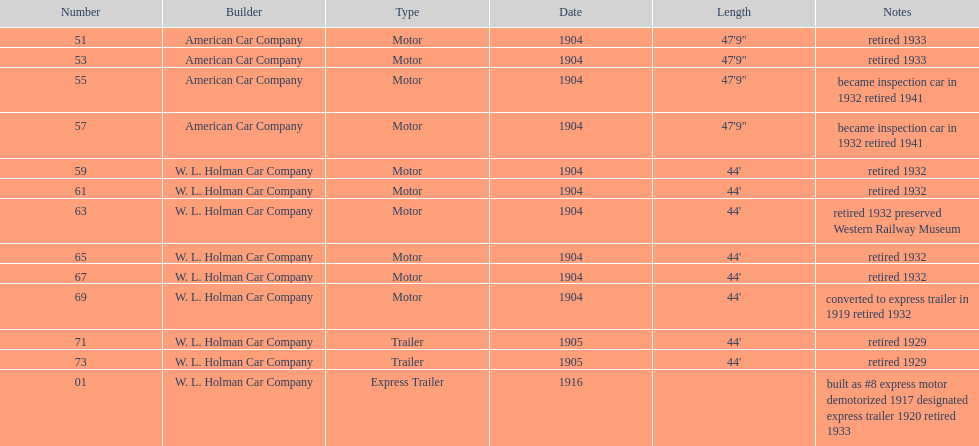In 1906, how many total rolling stock vehicles were in service? 12. 